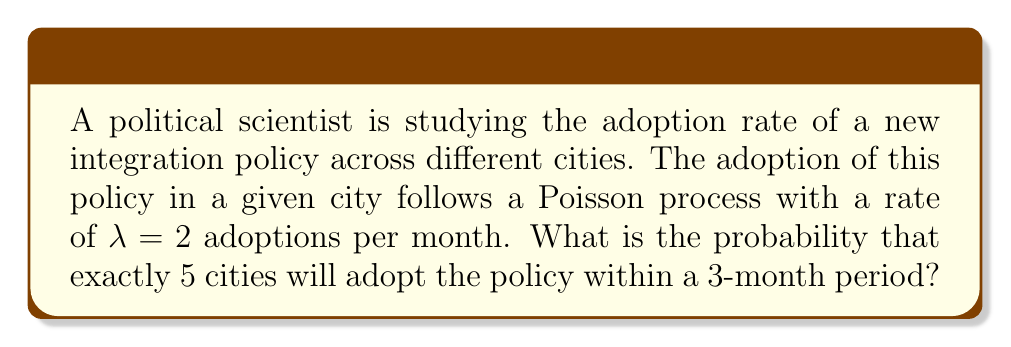Could you help me with this problem? To solve this problem, we'll use the Poisson distribution formula:

$$P(X = k) = \frac{e^{-\lambda t} (\lambda t)^k}{k!}$$

Where:
- $X$ is the number of events (adoptions)
- $k$ is the specific number of events we're interested in (5 in this case)
- $\lambda$ is the rate parameter (2 adoptions per month)
- $t$ is the time period (3 months)

Steps:
1) Calculate $\lambda t$:
   $\lambda t = 2 \text{ adoptions/month} \times 3 \text{ months} = 6$

2) Plug the values into the Poisson distribution formula:
   $$P(X = 5) = \frac{e^{-6} (6)^5}{5!}$$

3) Calculate:
   $$P(X = 5) = \frac{e^{-6} \times 7776}{120}$$

4) Evaluate:
   $$P(X = 5) \approx 0.1606$$

5) Convert to percentage:
   $0.1606 \times 100\% \approx 16.06\%$
Answer: 16.06% 